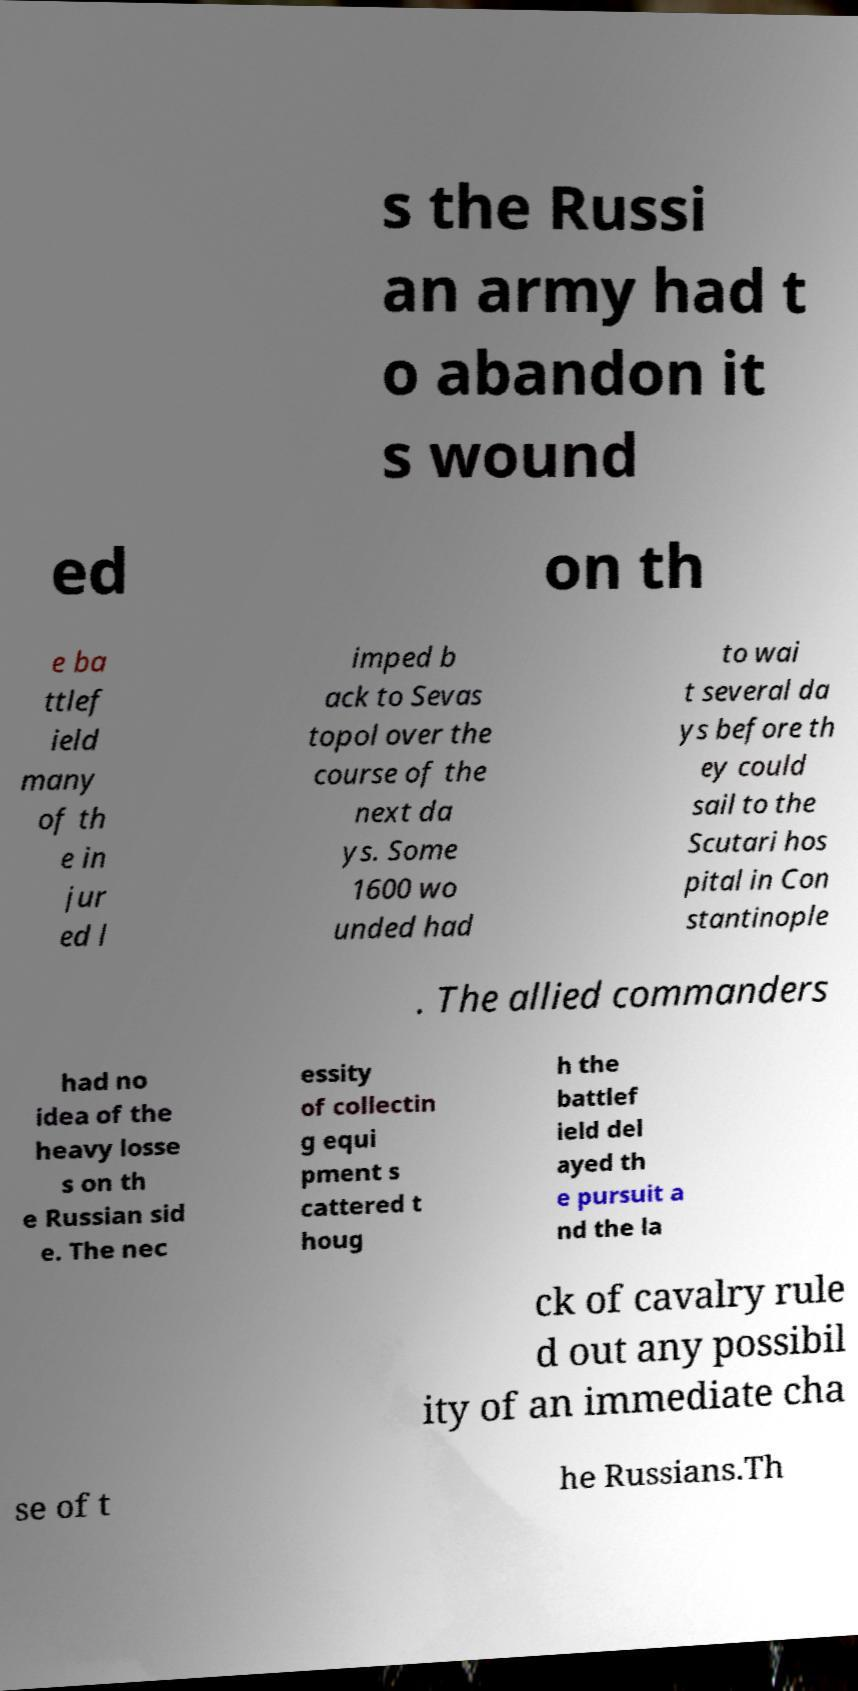Can you accurately transcribe the text from the provided image for me? s the Russi an army had t o abandon it s wound ed on th e ba ttlef ield many of th e in jur ed l imped b ack to Sevas topol over the course of the next da ys. Some 1600 wo unded had to wai t several da ys before th ey could sail to the Scutari hos pital in Con stantinople . The allied commanders had no idea of the heavy losse s on th e Russian sid e. The nec essity of collectin g equi pment s cattered t houg h the battlef ield del ayed th e pursuit a nd the la ck of cavalry rule d out any possibil ity of an immediate cha se of t he Russians.Th 